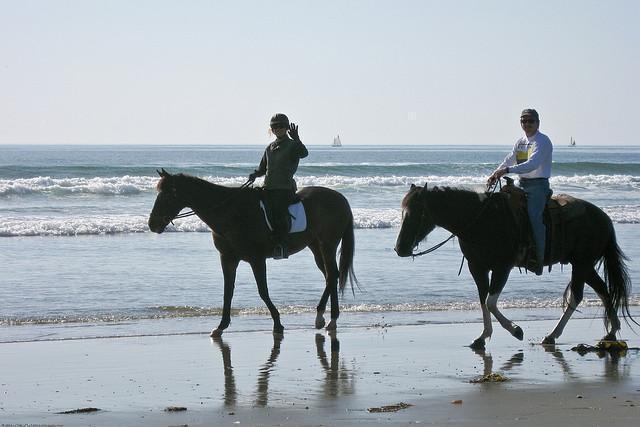Where do the riders here ride their horses?
Indicate the correct choice and explain in the format: 'Answer: answer
Rationale: rationale.'
Options: Farm, vocano, inner city, sea shore. Answer: sea shore.
Rationale: The horses are riding near the beach. 